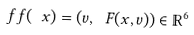<formula> <loc_0><loc_0><loc_500><loc_500>\ f f ( \ x ) = ( v , \ F ( x , v ) ) \in \mathbb { R } ^ { 6 }</formula> 